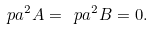<formula> <loc_0><loc_0><loc_500><loc_500>\ p a ^ { 2 } A = \ p a ^ { 2 } B = 0 .</formula> 